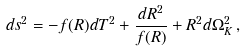Convert formula to latex. <formula><loc_0><loc_0><loc_500><loc_500>d s ^ { 2 } = - f ( R ) d T ^ { 2 } + \frac { d R ^ { 2 } } { f ( R ) } + R ^ { 2 } d \Omega _ { K } ^ { 2 } \, ,</formula> 